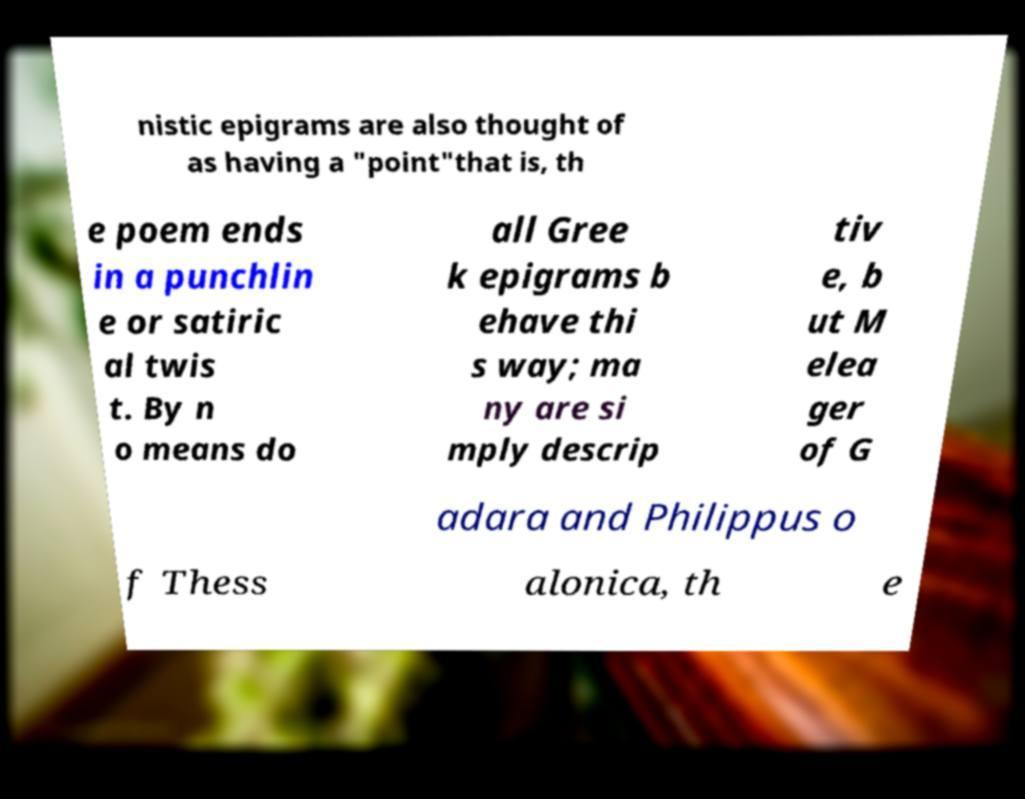For documentation purposes, I need the text within this image transcribed. Could you provide that? nistic epigrams are also thought of as having a "point"that is, th e poem ends in a punchlin e or satiric al twis t. By n o means do all Gree k epigrams b ehave thi s way; ma ny are si mply descrip tiv e, b ut M elea ger of G adara and Philippus o f Thess alonica, th e 